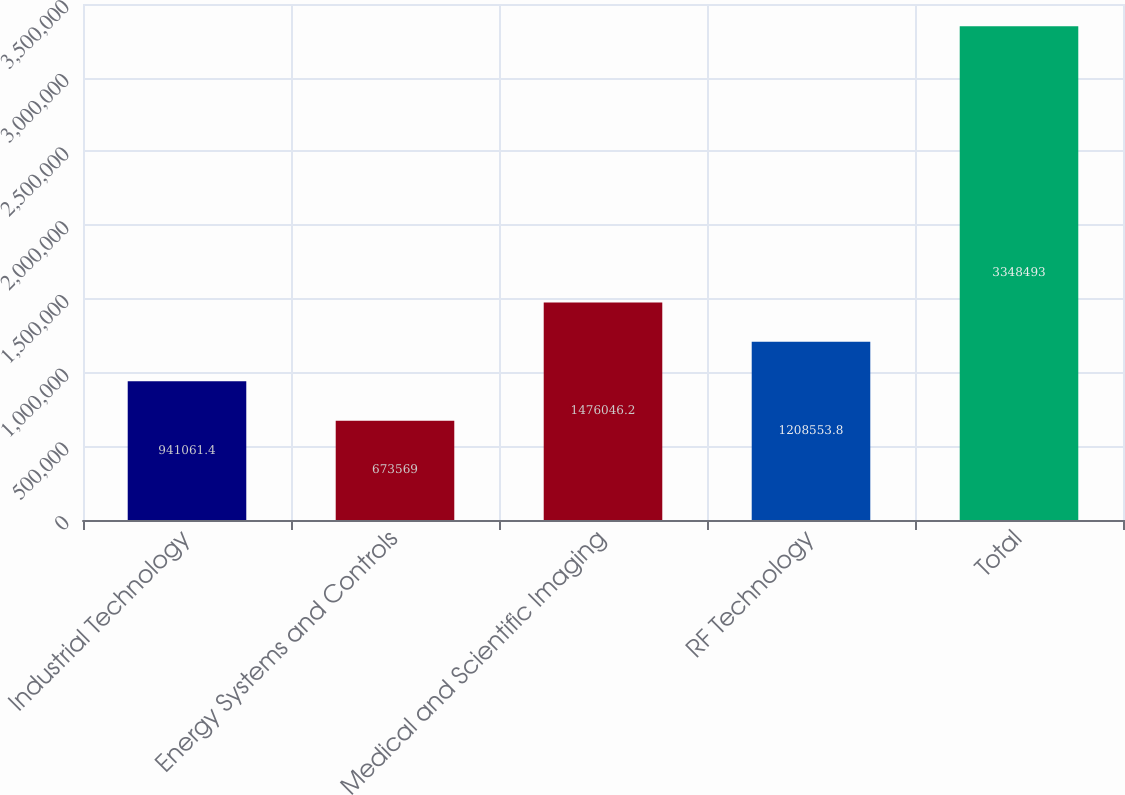Convert chart to OTSL. <chart><loc_0><loc_0><loc_500><loc_500><bar_chart><fcel>Industrial Technology<fcel>Energy Systems and Controls<fcel>Medical and Scientific Imaging<fcel>RF Technology<fcel>Total<nl><fcel>941061<fcel>673569<fcel>1.47605e+06<fcel>1.20855e+06<fcel>3.34849e+06<nl></chart> 